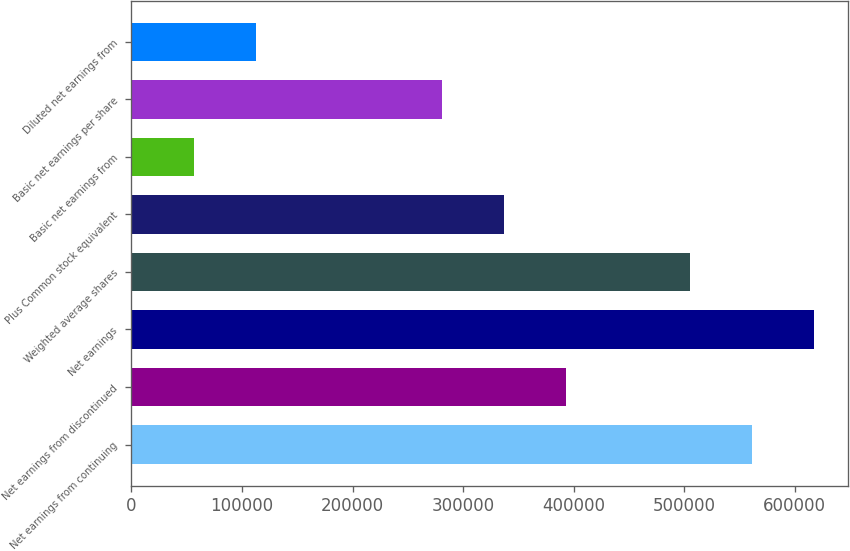<chart> <loc_0><loc_0><loc_500><loc_500><bar_chart><fcel>Net earnings from continuing<fcel>Net earnings from discontinued<fcel>Net earnings<fcel>Weighted average shares<fcel>Plus Common stock equivalent<fcel>Basic net earnings from<fcel>Basic net earnings per share<fcel>Diluted net earnings from<nl><fcel>561222<fcel>392855<fcel>617344<fcel>505100<fcel>336733<fcel>56122.4<fcel>280611<fcel>112245<nl></chart> 